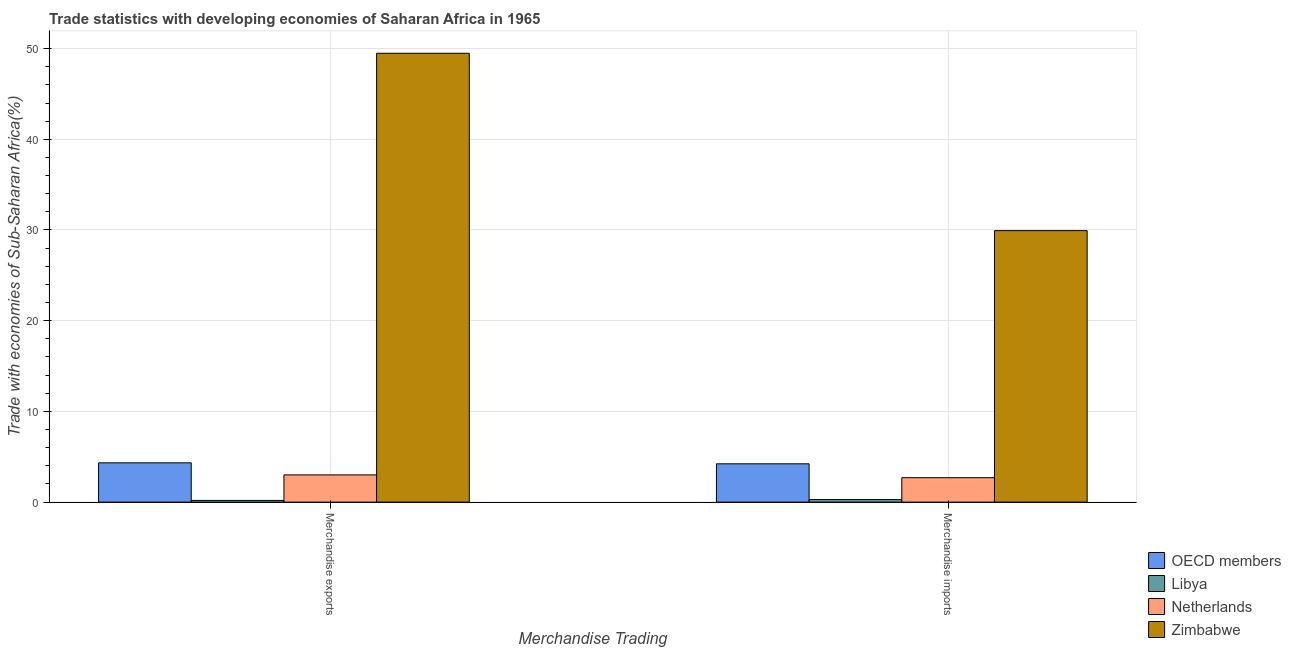How many groups of bars are there?
Your answer should be very brief. 2. Are the number of bars on each tick of the X-axis equal?
Provide a succinct answer. Yes. What is the label of the 2nd group of bars from the left?
Keep it short and to the point. Merchandise imports. What is the merchandise exports in Zimbabwe?
Your response must be concise. 49.48. Across all countries, what is the maximum merchandise exports?
Make the answer very short. 49.48. Across all countries, what is the minimum merchandise imports?
Provide a succinct answer. 0.28. In which country was the merchandise imports maximum?
Make the answer very short. Zimbabwe. In which country was the merchandise exports minimum?
Your answer should be compact. Libya. What is the total merchandise exports in the graph?
Keep it short and to the point. 57.01. What is the difference between the merchandise exports in Zimbabwe and that in Libya?
Make the answer very short. 49.3. What is the difference between the merchandise exports in OECD members and the merchandise imports in Netherlands?
Provide a short and direct response. 1.64. What is the average merchandise imports per country?
Give a very brief answer. 9.28. What is the difference between the merchandise exports and merchandise imports in Zimbabwe?
Offer a very short reply. 19.55. What is the ratio of the merchandise imports in Libya to that in Zimbabwe?
Your response must be concise. 0.01. What does the 1st bar from the right in Merchandise exports represents?
Ensure brevity in your answer.  Zimbabwe. Are all the bars in the graph horizontal?
Give a very brief answer. No. How many countries are there in the graph?
Your answer should be compact. 4. What is the difference between two consecutive major ticks on the Y-axis?
Give a very brief answer. 10. Are the values on the major ticks of Y-axis written in scientific E-notation?
Give a very brief answer. No. Does the graph contain any zero values?
Provide a succinct answer. No. Where does the legend appear in the graph?
Your response must be concise. Bottom right. What is the title of the graph?
Provide a succinct answer. Trade statistics with developing economies of Saharan Africa in 1965. What is the label or title of the X-axis?
Keep it short and to the point. Merchandise Trading. What is the label or title of the Y-axis?
Offer a very short reply. Trade with economies of Sub-Saharan Africa(%). What is the Trade with economies of Sub-Saharan Africa(%) in OECD members in Merchandise exports?
Provide a succinct answer. 4.33. What is the Trade with economies of Sub-Saharan Africa(%) of Libya in Merchandise exports?
Provide a succinct answer. 0.19. What is the Trade with economies of Sub-Saharan Africa(%) in Netherlands in Merchandise exports?
Your answer should be compact. 3. What is the Trade with economies of Sub-Saharan Africa(%) of Zimbabwe in Merchandise exports?
Make the answer very short. 49.48. What is the Trade with economies of Sub-Saharan Africa(%) in OECD members in Merchandise imports?
Ensure brevity in your answer.  4.22. What is the Trade with economies of Sub-Saharan Africa(%) of Libya in Merchandise imports?
Provide a succinct answer. 0.28. What is the Trade with economies of Sub-Saharan Africa(%) of Netherlands in Merchandise imports?
Your answer should be compact. 2.7. What is the Trade with economies of Sub-Saharan Africa(%) in Zimbabwe in Merchandise imports?
Your answer should be compact. 29.93. Across all Merchandise Trading, what is the maximum Trade with economies of Sub-Saharan Africa(%) of OECD members?
Provide a short and direct response. 4.33. Across all Merchandise Trading, what is the maximum Trade with economies of Sub-Saharan Africa(%) in Libya?
Your answer should be very brief. 0.28. Across all Merchandise Trading, what is the maximum Trade with economies of Sub-Saharan Africa(%) in Netherlands?
Keep it short and to the point. 3. Across all Merchandise Trading, what is the maximum Trade with economies of Sub-Saharan Africa(%) of Zimbabwe?
Offer a very short reply. 49.48. Across all Merchandise Trading, what is the minimum Trade with economies of Sub-Saharan Africa(%) of OECD members?
Your answer should be very brief. 4.22. Across all Merchandise Trading, what is the minimum Trade with economies of Sub-Saharan Africa(%) in Libya?
Give a very brief answer. 0.19. Across all Merchandise Trading, what is the minimum Trade with economies of Sub-Saharan Africa(%) in Netherlands?
Your response must be concise. 2.7. Across all Merchandise Trading, what is the minimum Trade with economies of Sub-Saharan Africa(%) in Zimbabwe?
Your answer should be very brief. 29.93. What is the total Trade with economies of Sub-Saharan Africa(%) in OECD members in the graph?
Provide a succinct answer. 8.55. What is the total Trade with economies of Sub-Saharan Africa(%) in Libya in the graph?
Provide a succinct answer. 0.47. What is the total Trade with economies of Sub-Saharan Africa(%) of Netherlands in the graph?
Make the answer very short. 5.7. What is the total Trade with economies of Sub-Saharan Africa(%) of Zimbabwe in the graph?
Provide a short and direct response. 79.41. What is the difference between the Trade with economies of Sub-Saharan Africa(%) in OECD members in Merchandise exports and that in Merchandise imports?
Your answer should be compact. 0.11. What is the difference between the Trade with economies of Sub-Saharan Africa(%) in Libya in Merchandise exports and that in Merchandise imports?
Your answer should be compact. -0.09. What is the difference between the Trade with economies of Sub-Saharan Africa(%) of Netherlands in Merchandise exports and that in Merchandise imports?
Give a very brief answer. 0.31. What is the difference between the Trade with economies of Sub-Saharan Africa(%) in Zimbabwe in Merchandise exports and that in Merchandise imports?
Your answer should be compact. 19.55. What is the difference between the Trade with economies of Sub-Saharan Africa(%) of OECD members in Merchandise exports and the Trade with economies of Sub-Saharan Africa(%) of Libya in Merchandise imports?
Your answer should be compact. 4.05. What is the difference between the Trade with economies of Sub-Saharan Africa(%) in OECD members in Merchandise exports and the Trade with economies of Sub-Saharan Africa(%) in Netherlands in Merchandise imports?
Provide a succinct answer. 1.64. What is the difference between the Trade with economies of Sub-Saharan Africa(%) of OECD members in Merchandise exports and the Trade with economies of Sub-Saharan Africa(%) of Zimbabwe in Merchandise imports?
Your answer should be very brief. -25.6. What is the difference between the Trade with economies of Sub-Saharan Africa(%) of Libya in Merchandise exports and the Trade with economies of Sub-Saharan Africa(%) of Netherlands in Merchandise imports?
Your answer should be compact. -2.51. What is the difference between the Trade with economies of Sub-Saharan Africa(%) of Libya in Merchandise exports and the Trade with economies of Sub-Saharan Africa(%) of Zimbabwe in Merchandise imports?
Your answer should be very brief. -29.74. What is the difference between the Trade with economies of Sub-Saharan Africa(%) of Netherlands in Merchandise exports and the Trade with economies of Sub-Saharan Africa(%) of Zimbabwe in Merchandise imports?
Provide a succinct answer. -26.93. What is the average Trade with economies of Sub-Saharan Africa(%) in OECD members per Merchandise Trading?
Ensure brevity in your answer.  4.28. What is the average Trade with economies of Sub-Saharan Africa(%) in Libya per Merchandise Trading?
Your answer should be compact. 0.23. What is the average Trade with economies of Sub-Saharan Africa(%) in Netherlands per Merchandise Trading?
Provide a succinct answer. 2.85. What is the average Trade with economies of Sub-Saharan Africa(%) in Zimbabwe per Merchandise Trading?
Offer a terse response. 39.71. What is the difference between the Trade with economies of Sub-Saharan Africa(%) of OECD members and Trade with economies of Sub-Saharan Africa(%) of Libya in Merchandise exports?
Offer a terse response. 4.14. What is the difference between the Trade with economies of Sub-Saharan Africa(%) in OECD members and Trade with economies of Sub-Saharan Africa(%) in Netherlands in Merchandise exports?
Your answer should be very brief. 1.33. What is the difference between the Trade with economies of Sub-Saharan Africa(%) in OECD members and Trade with economies of Sub-Saharan Africa(%) in Zimbabwe in Merchandise exports?
Your response must be concise. -45.15. What is the difference between the Trade with economies of Sub-Saharan Africa(%) in Libya and Trade with economies of Sub-Saharan Africa(%) in Netherlands in Merchandise exports?
Keep it short and to the point. -2.81. What is the difference between the Trade with economies of Sub-Saharan Africa(%) of Libya and Trade with economies of Sub-Saharan Africa(%) of Zimbabwe in Merchandise exports?
Give a very brief answer. -49.3. What is the difference between the Trade with economies of Sub-Saharan Africa(%) of Netherlands and Trade with economies of Sub-Saharan Africa(%) of Zimbabwe in Merchandise exports?
Offer a very short reply. -46.48. What is the difference between the Trade with economies of Sub-Saharan Africa(%) of OECD members and Trade with economies of Sub-Saharan Africa(%) of Libya in Merchandise imports?
Keep it short and to the point. 3.94. What is the difference between the Trade with economies of Sub-Saharan Africa(%) in OECD members and Trade with economies of Sub-Saharan Africa(%) in Netherlands in Merchandise imports?
Your answer should be very brief. 1.53. What is the difference between the Trade with economies of Sub-Saharan Africa(%) in OECD members and Trade with economies of Sub-Saharan Africa(%) in Zimbabwe in Merchandise imports?
Keep it short and to the point. -25.71. What is the difference between the Trade with economies of Sub-Saharan Africa(%) in Libya and Trade with economies of Sub-Saharan Africa(%) in Netherlands in Merchandise imports?
Provide a succinct answer. -2.41. What is the difference between the Trade with economies of Sub-Saharan Africa(%) in Libya and Trade with economies of Sub-Saharan Africa(%) in Zimbabwe in Merchandise imports?
Ensure brevity in your answer.  -29.65. What is the difference between the Trade with economies of Sub-Saharan Africa(%) of Netherlands and Trade with economies of Sub-Saharan Africa(%) of Zimbabwe in Merchandise imports?
Give a very brief answer. -27.24. What is the ratio of the Trade with economies of Sub-Saharan Africa(%) in OECD members in Merchandise exports to that in Merchandise imports?
Offer a terse response. 1.03. What is the ratio of the Trade with economies of Sub-Saharan Africa(%) of Libya in Merchandise exports to that in Merchandise imports?
Your answer should be compact. 0.67. What is the ratio of the Trade with economies of Sub-Saharan Africa(%) of Netherlands in Merchandise exports to that in Merchandise imports?
Offer a very short reply. 1.11. What is the ratio of the Trade with economies of Sub-Saharan Africa(%) of Zimbabwe in Merchandise exports to that in Merchandise imports?
Keep it short and to the point. 1.65. What is the difference between the highest and the second highest Trade with economies of Sub-Saharan Africa(%) in OECD members?
Keep it short and to the point. 0.11. What is the difference between the highest and the second highest Trade with economies of Sub-Saharan Africa(%) of Libya?
Your answer should be very brief. 0.09. What is the difference between the highest and the second highest Trade with economies of Sub-Saharan Africa(%) of Netherlands?
Your answer should be compact. 0.31. What is the difference between the highest and the second highest Trade with economies of Sub-Saharan Africa(%) in Zimbabwe?
Your answer should be very brief. 19.55. What is the difference between the highest and the lowest Trade with economies of Sub-Saharan Africa(%) in OECD members?
Ensure brevity in your answer.  0.11. What is the difference between the highest and the lowest Trade with economies of Sub-Saharan Africa(%) in Libya?
Your answer should be compact. 0.09. What is the difference between the highest and the lowest Trade with economies of Sub-Saharan Africa(%) of Netherlands?
Your answer should be compact. 0.31. What is the difference between the highest and the lowest Trade with economies of Sub-Saharan Africa(%) in Zimbabwe?
Make the answer very short. 19.55. 